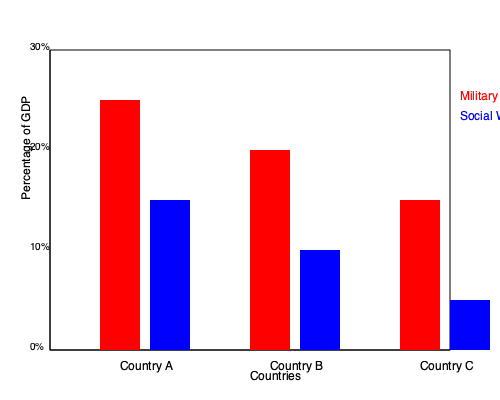Based on the bar chart comparing military spending and social welfare expenditures in three post-war nations, which country shows the greatest disparity between these two categories, and what potential implications might this have for sustainable peace-building efforts? To answer this question, we need to analyze the data presented in the bar chart for each country:

1. Examine the data for each country:
   a) Country A: 
      - Military spending: ~25% of GDP
      - Social welfare: ~15% of GDP
      - Difference: ~10%
   
   b) Country B:
      - Military spending: ~20% of GDP
      - Social welfare: ~10% of GDP
      - Difference: ~10%
   
   c) Country C:
      - Military spending: ~15% of GDP
      - Social welfare: ~5% of GDP
      - Difference: ~10%

2. Compare the differences:
   All three countries show a difference of about 10% between military spending and social welfare expenditures.

3. Identify the country with the greatest disparity:
   While the absolute difference is similar, Country C has the greatest relative disparity. Its military spending is three times higher than its social welfare spending, compared to the roughly 1.6:1 ratio in Countries A and B.

4. Consider implications for sustainable peace-building:
   a) High military spending relative to social welfare may indicate:
      - Ongoing security concerns
      - Potential for renewed conflict
      - Limited resources for addressing root causes of conflict
   
   b) Low social welfare spending may lead to:
      - Insufficient support for vulnerable populations
      - Increased social inequality
      - Reduced opportunities for reconciliation and community building

   c) This imbalance could hinder sustainable peace by:
      - Perpetuating a cycle of militarization
      - Neglecting social and economic development
      - Potentially fueling grievances that led to the initial conflict

5. Conclusion:
   Country C shows the greatest relative disparity between military and social welfare spending, which could pose significant challenges to sustainable peace-building efforts.
Answer: Country C; greatest relative disparity may hinder sustainable peace by neglecting social development and perpetuating militarization. 